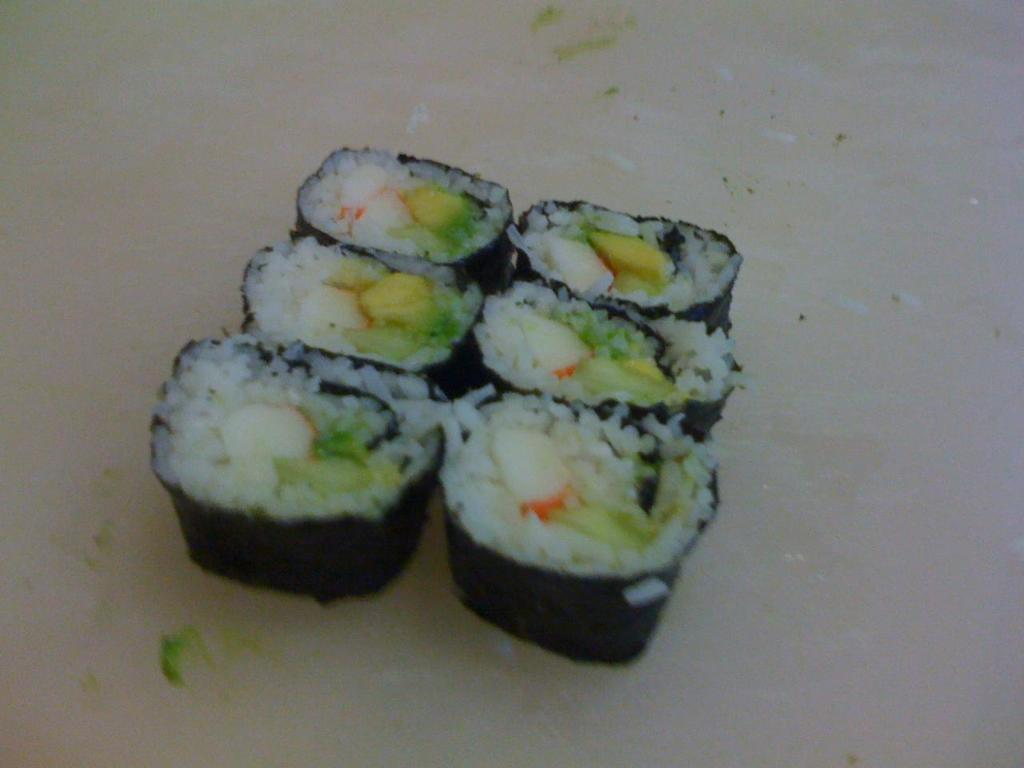What is the main subject of the image? The main subject of the image is food. Can you describe the surface on which the food is placed? The food is on a white surface. What type of engine is visible in the image? There is no engine present in the image; it features food on a white surface. What substance is being used to create a way in the image? There is no substance or way being created in the image; it only shows food on a white surface. 